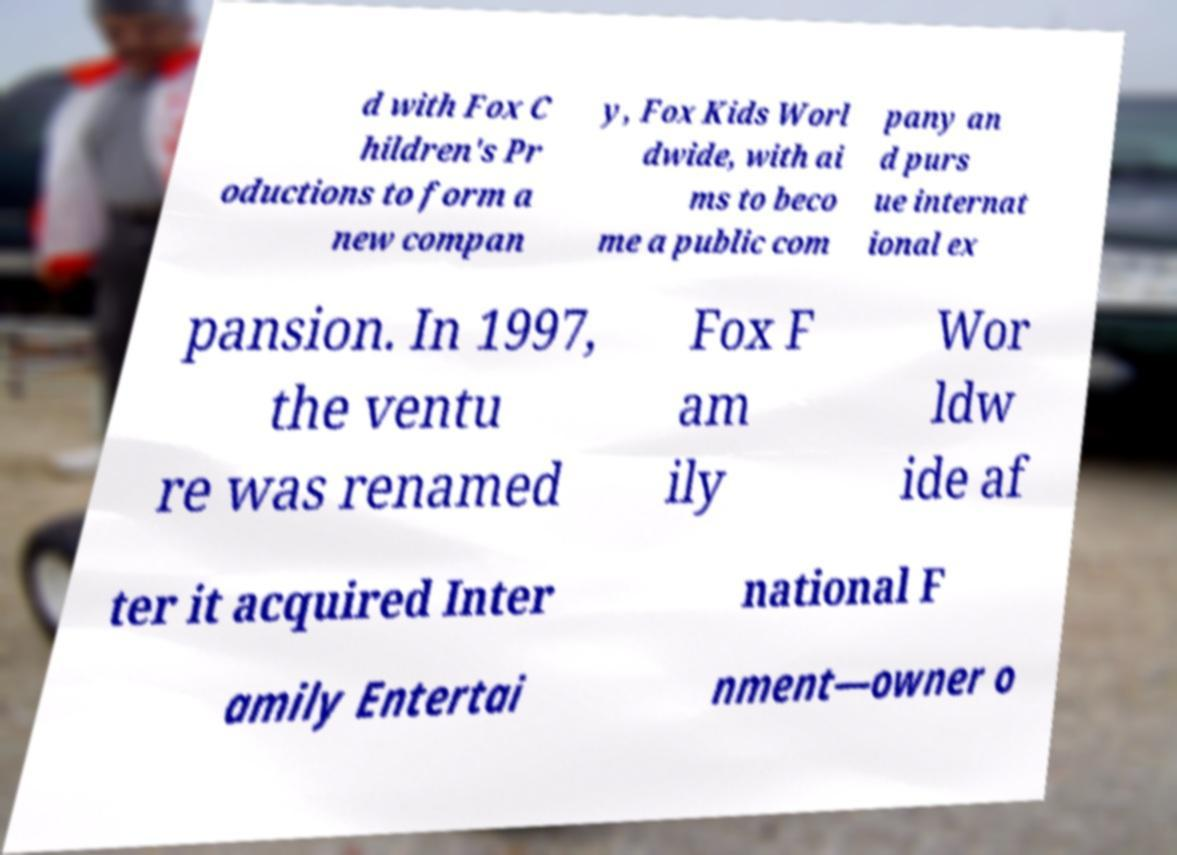Could you assist in decoding the text presented in this image and type it out clearly? d with Fox C hildren's Pr oductions to form a new compan y, Fox Kids Worl dwide, with ai ms to beco me a public com pany an d purs ue internat ional ex pansion. In 1997, the ventu re was renamed Fox F am ily Wor ldw ide af ter it acquired Inter national F amily Entertai nment—owner o 